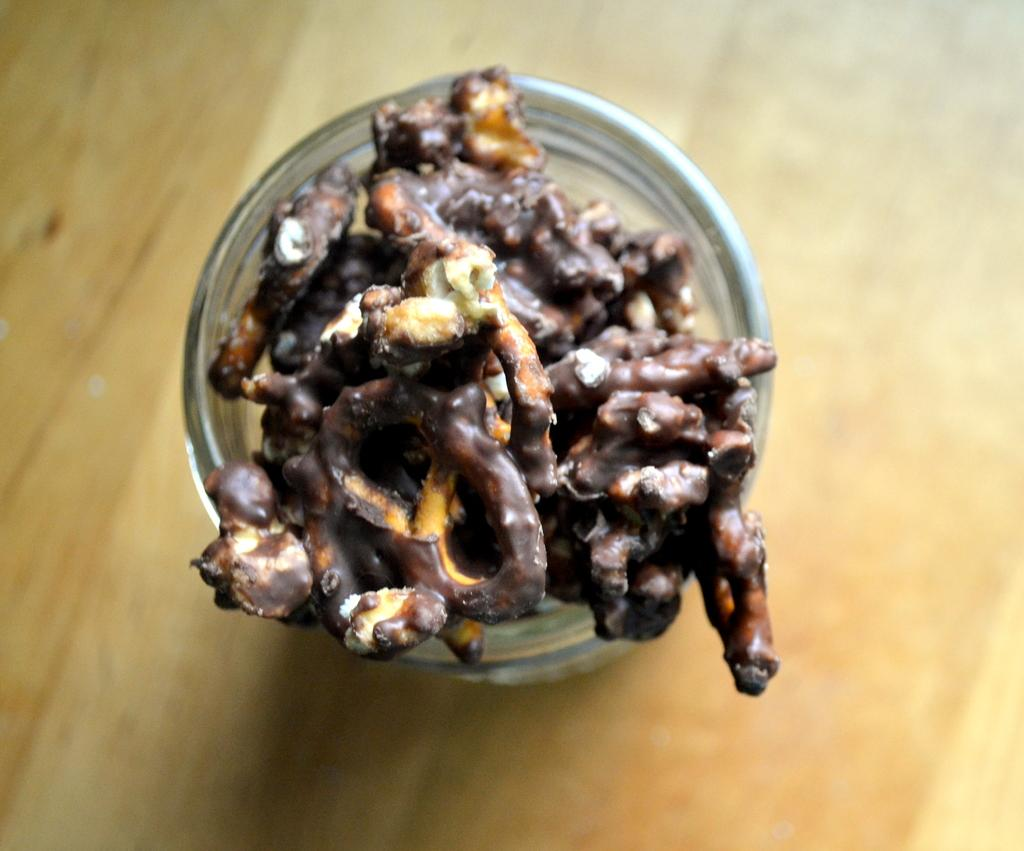What type of container is visible in the image? There is a glass bowl in the image. What is the color of the surface beneath the bowl? The bowl is on a cream-colored surface. What is inside the bowl? There is a food item in the bowl. What colors can be seen in the food item? The food item is cream and brown in color. What is the title of the book that the ant is reading in the image? There is no book or ant present in the image, so it is not possible to determine the title of a book or the presence of an ant. 